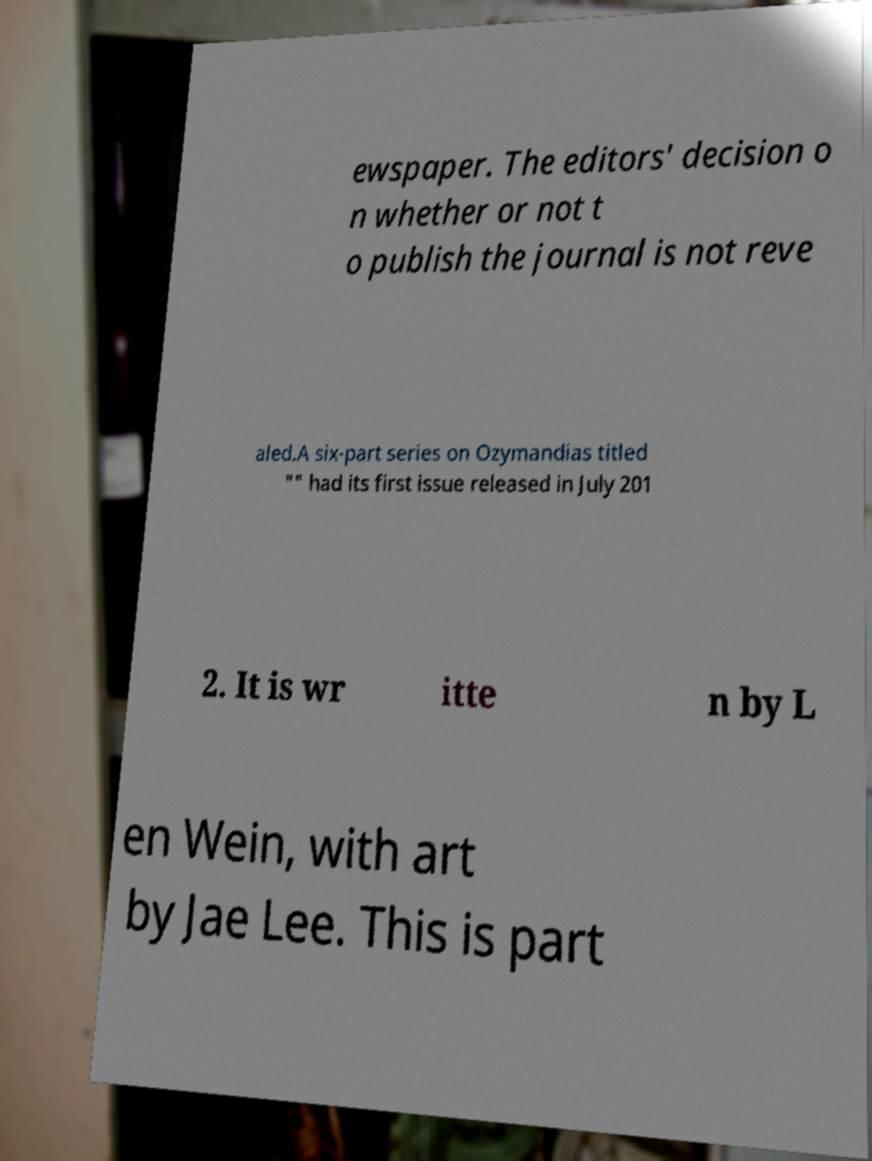What messages or text are displayed in this image? I need them in a readable, typed format. ewspaper. The editors' decision o n whether or not t o publish the journal is not reve aled.A six-part series on Ozymandias titled "" had its first issue released in July 201 2. It is wr itte n by L en Wein, with art by Jae Lee. This is part 